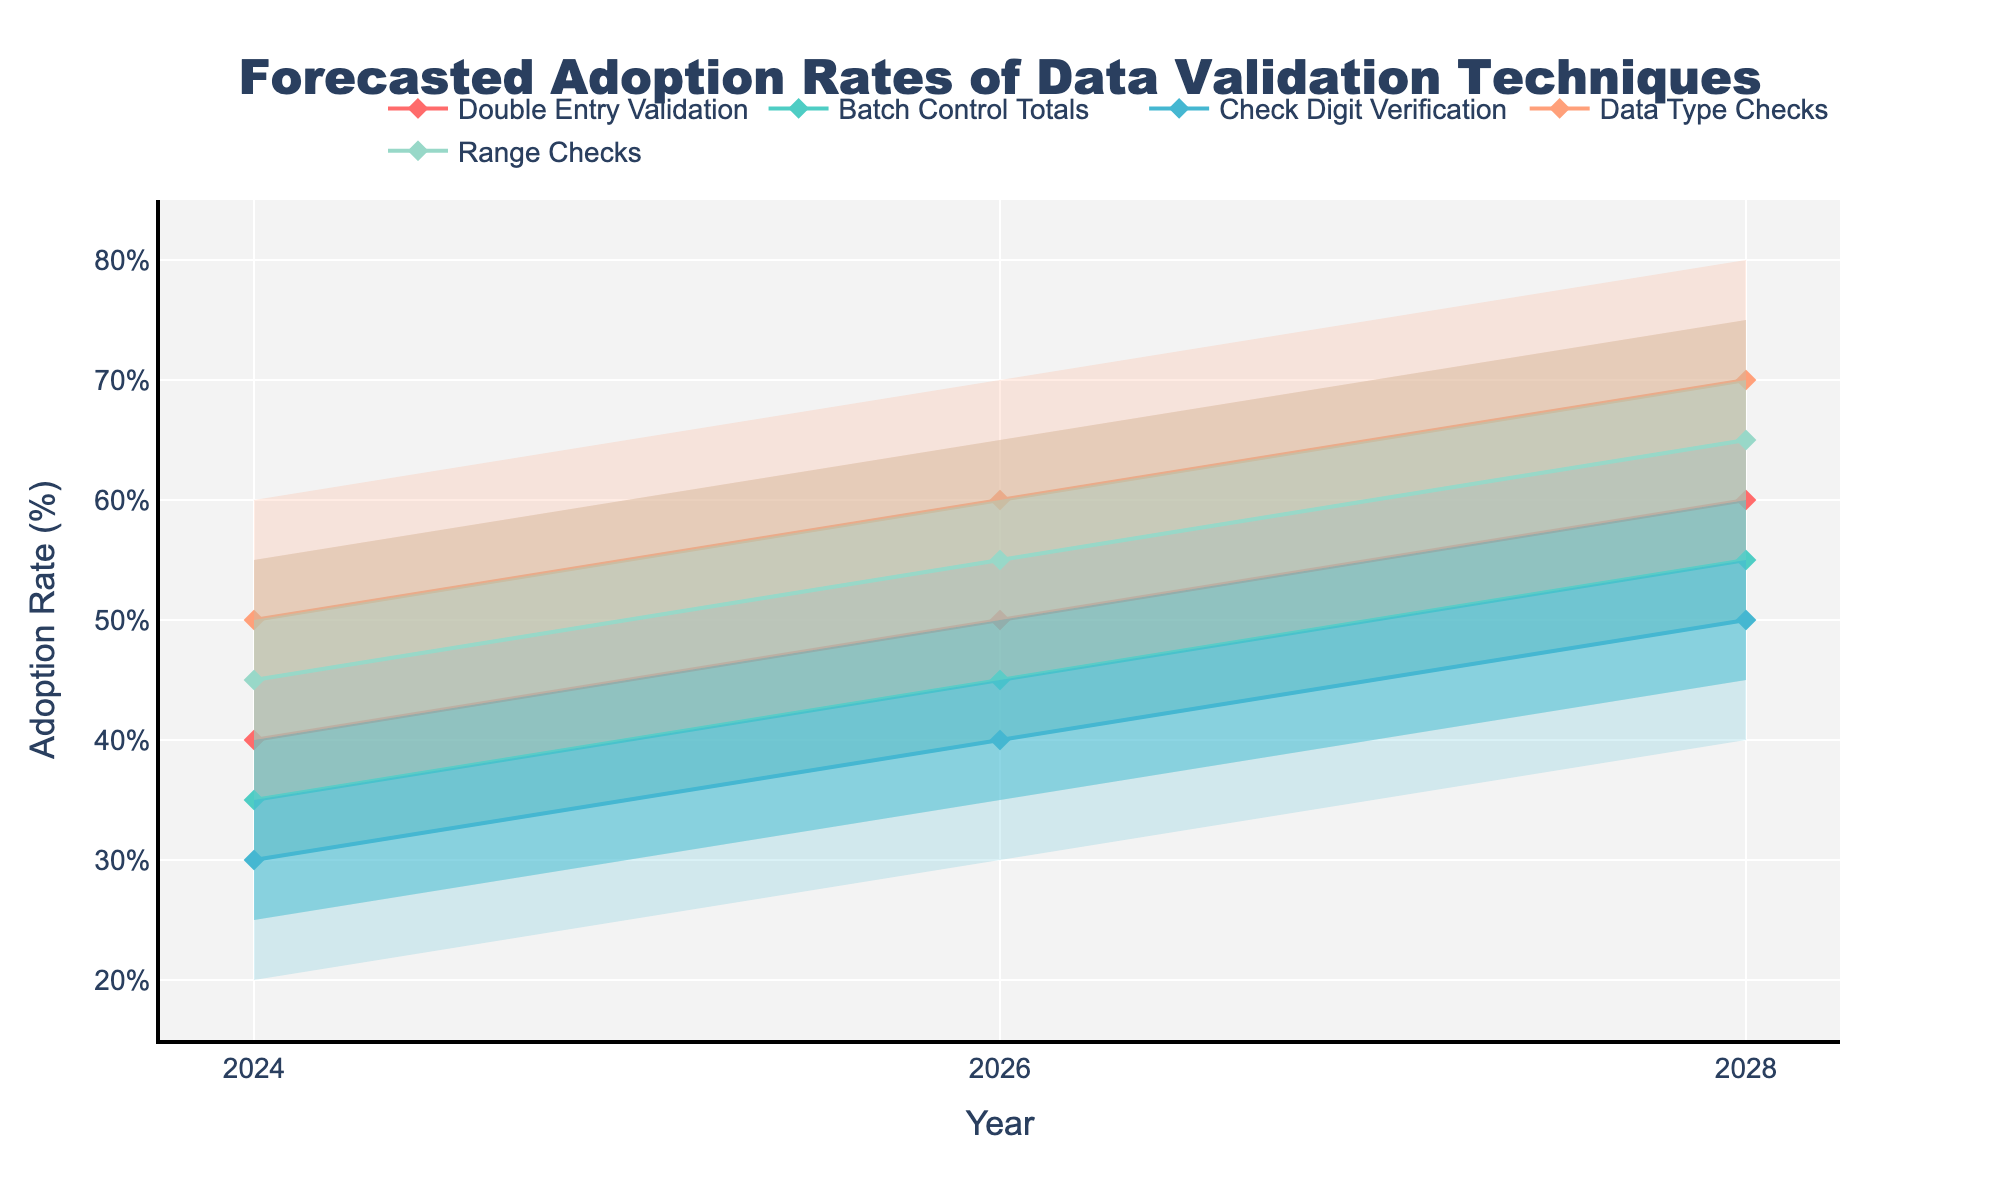What is the title of the chart? The title is displayed at the top center of the chart. It reads "Forecasted Adoption Rates of Data Validation Techniques."
Answer: Forecasted Adoption Rates of Data Validation Techniques How many different data validation techniques are depicted in the chart? The legend at the bottom of the chart shows five different data validation techniques.
Answer: Five Which data validation technique has the highest forecasted adoption rate in the year 2028 for the median range? Look at the lines for the median (mid) forecast for each technique in the year 2028. The Data Type Checks technique reaches 70%, which is the highest.
Answer: Data Type Checks How does the adoption rate of Double Entry Validation in 2026 compare to its rate in 2024? In 2024, Double Entry Validation has a median adoption rate of 40%. In 2026, this increases to 50%. The difference is 10%.
Answer: Increased by 10% What is the average high forecasted adoption rate in 2028 for all techniques? Look at the "High" values for each technique in 2028: Double Entry Validation (70%), Batch Control Totals (65%), Check Digit Verification (60%), Data Type Checks (80%), and Range Checks (75%). Add these together and divide by the number of techniques: (70+65+60+80+75)/5 = 70%.
Answer: 70% Which technique has the narrowest forecasted range of adoption rates in the year 2024? Calculate the range for each technique by subtracting the Low forecast from the High forecast. The technique with the smallest difference is Batch Control Totals (45-25=20%).
Answer: Batch Control Totals Are any techniques expected to have the same median adoption rate in 2026? In 2026, the mid values for Batch Control Totals and Range Checks are both 55%.
Answer: Yes, Batch Control Totals and Range Checks Which technique shows the most significant increase in its median adoption rate from 2024 to 2028? Calculate the increase for each technique: Double Entry Validation (60-40=20%), Batch Control Totals (55-35=20%), Check Digit Verification (50-30=20%), Data Type Checks (70-50=20%), Range Checks (65-45=20%). All techniques show a 20% increase in their median adoption rates.
Answer: All techniques show a 20% increase Which year shows the highest forecasted variability in the adoption rate of Data Type Checks? Compare the range (High-Low) for Data Type Checks in each year: 2024 (60-40=20%), 2026 (70-50=20%), 2028 (80-60=20%). The variability remains the same across all years, which is 20%.
Answer: The variability remains the same across all years What is the lowest forecasted adoption rate for Check Digit Verification in 2026 in any confidence interval? For Check Digit Verification in 2026, the lowest rate is in the Low forecast interval, which is 30%.
Answer: 30% 